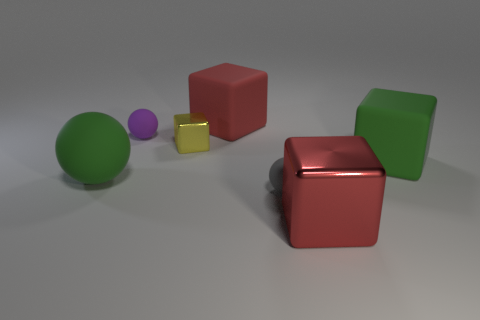What number of balls are either gray rubber things or brown rubber objects?
Provide a short and direct response. 1. Are there any other things that are the same material as the small purple thing?
Provide a succinct answer. Yes. There is a red block right of the big block that is to the left of the block in front of the big matte sphere; what is its material?
Your answer should be very brief. Metal. What is the material of the large object that is the same color as the large rubber sphere?
Your response must be concise. Rubber. How many tiny brown spheres have the same material as the yellow thing?
Offer a terse response. 0. Does the metallic object that is in front of the green sphere have the same size as the small yellow block?
Provide a succinct answer. No. There is another tiny object that is the same material as the tiny purple object; what color is it?
Offer a terse response. Gray. Is there anything else that has the same size as the green matte sphere?
Provide a succinct answer. Yes. There is a tiny purple sphere; what number of green blocks are in front of it?
Your answer should be very brief. 1. There is a matte block that is in front of the tiny yellow object; does it have the same color as the matte thing to the left of the purple sphere?
Ensure brevity in your answer.  Yes. 